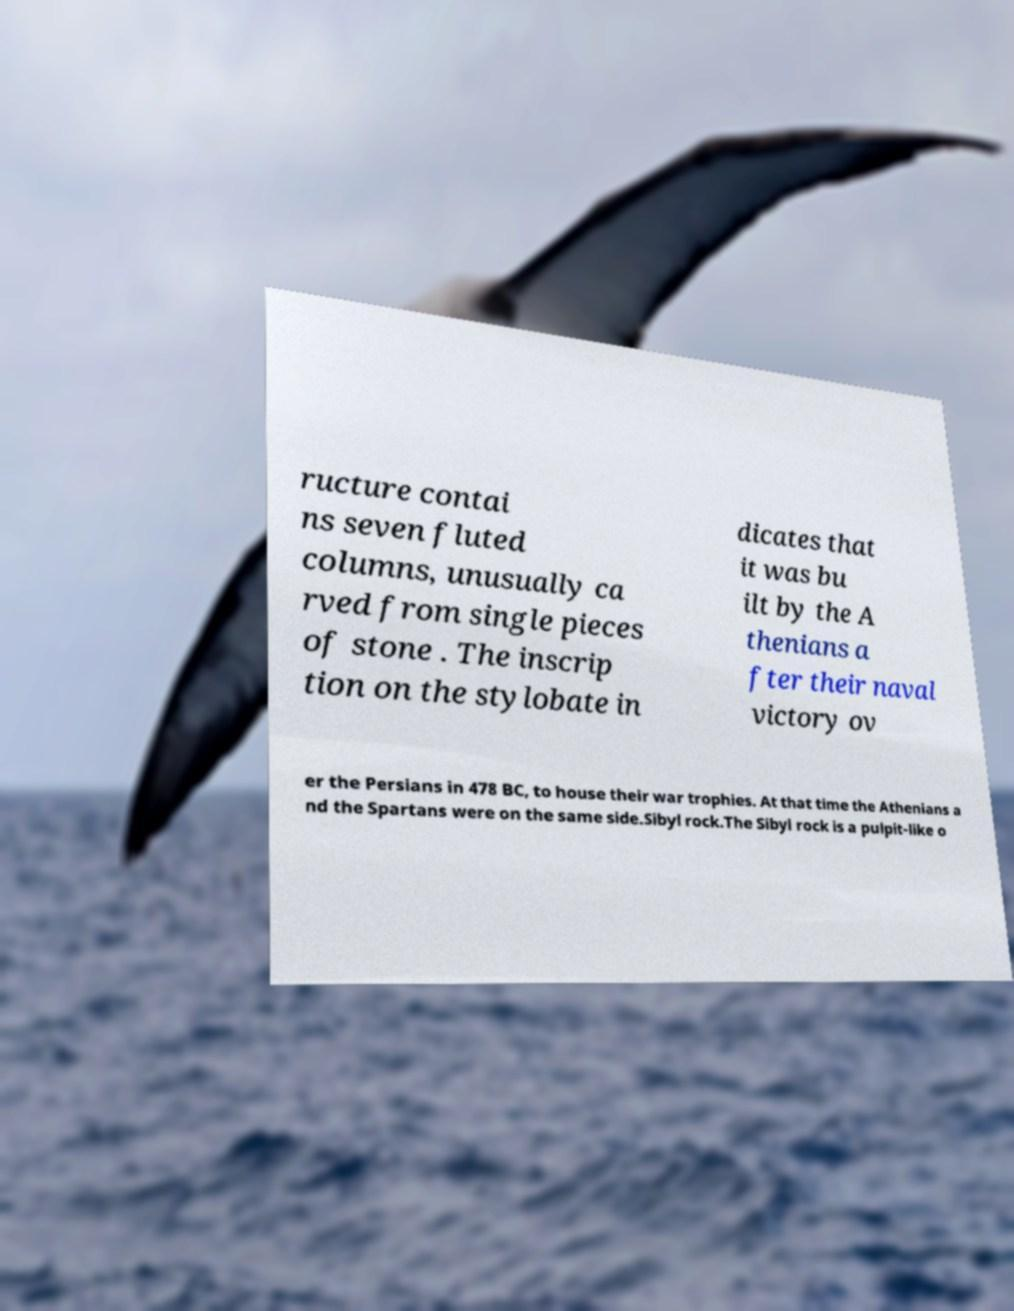Could you assist in decoding the text presented in this image and type it out clearly? ructure contai ns seven fluted columns, unusually ca rved from single pieces of stone . The inscrip tion on the stylobate in dicates that it was bu ilt by the A thenians a fter their naval victory ov er the Persians in 478 BC, to house their war trophies. At that time the Athenians a nd the Spartans were on the same side.Sibyl rock.The Sibyl rock is a pulpit-like o 